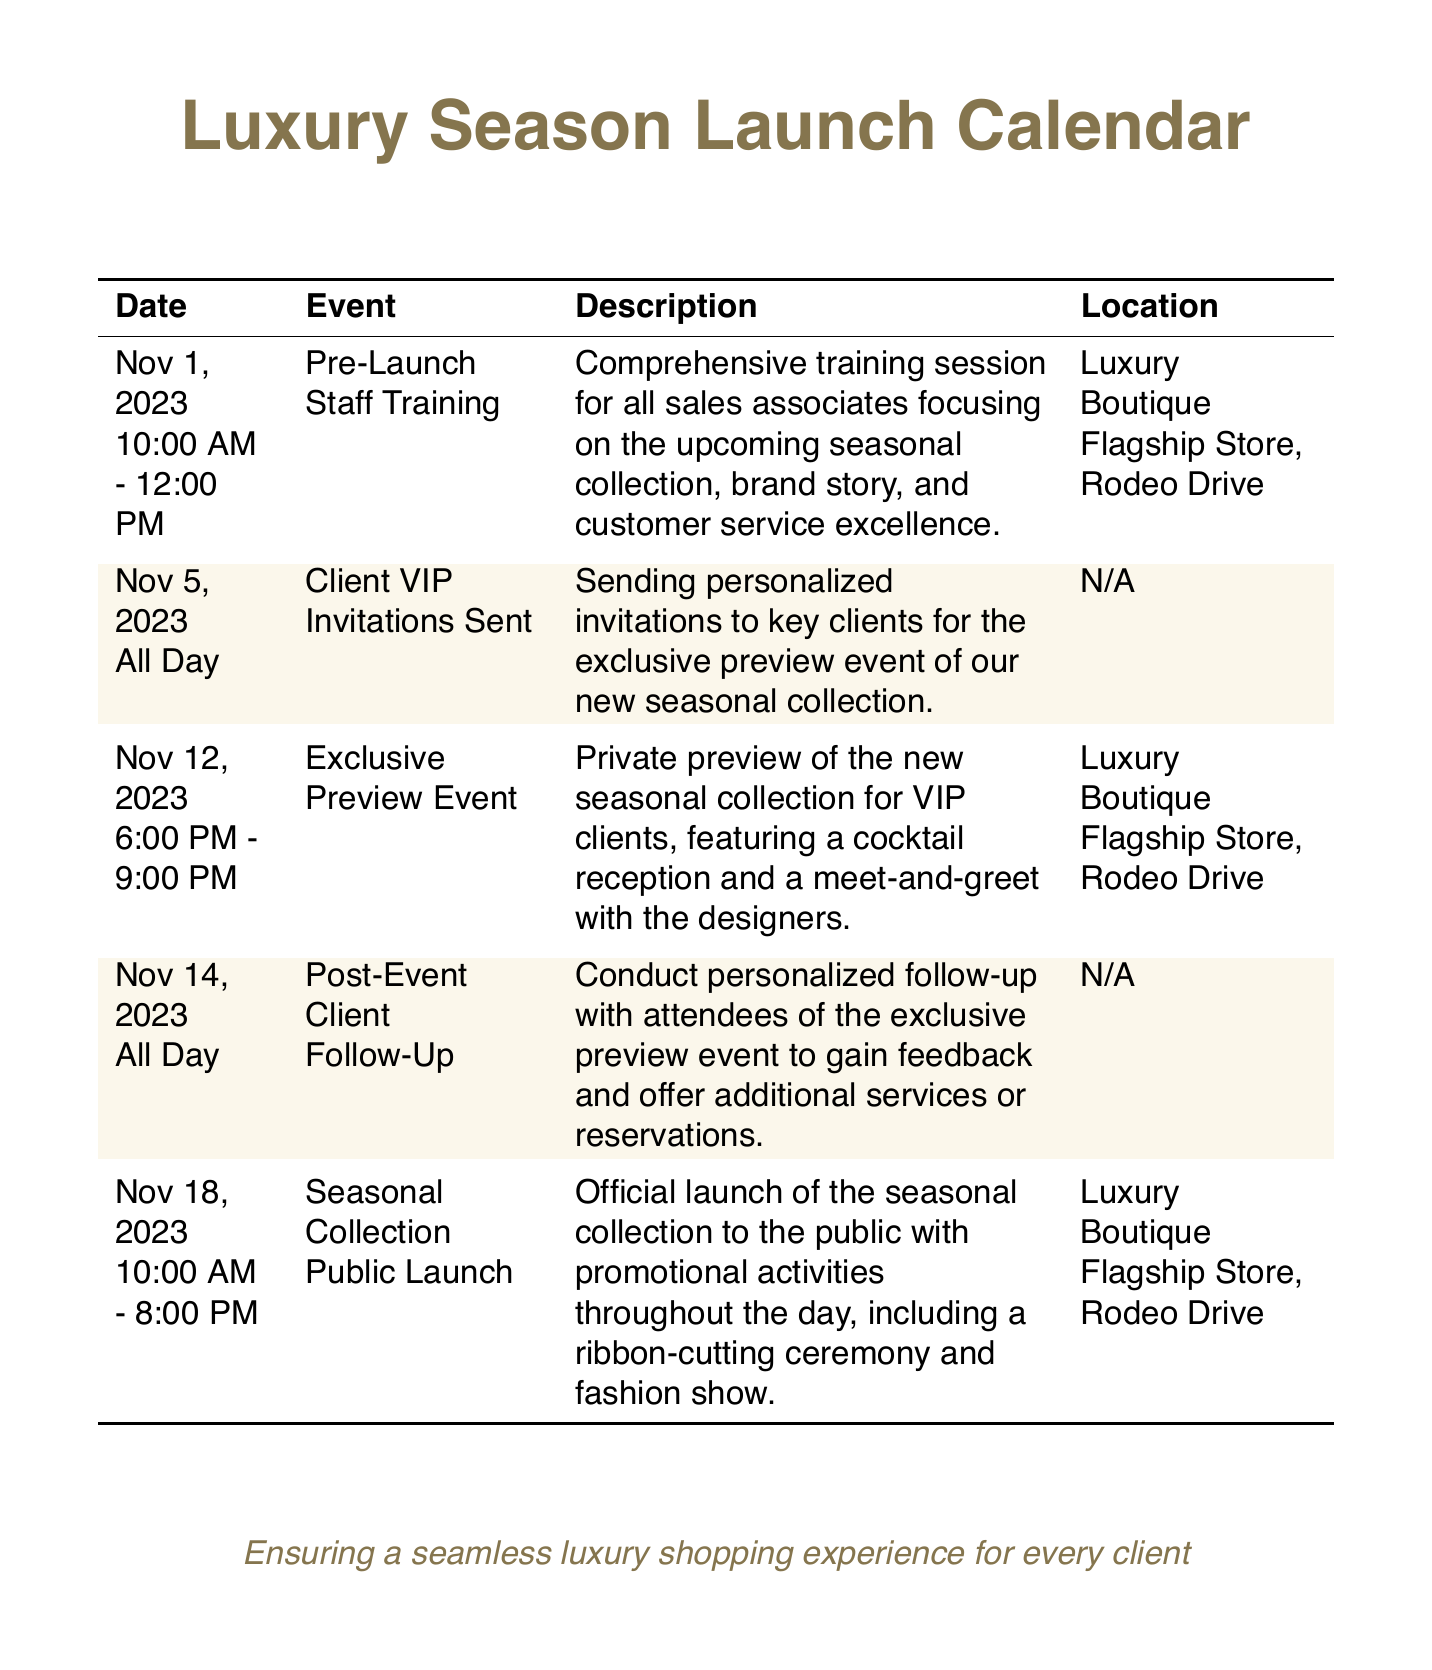what date is the pre-launch staff training scheduled for? The pre-launch staff training is scheduled for November 1, 2023, as mentioned in the document.
Answer: November 1, 2023 what time does the exclusive preview event start? The exclusive preview event starts at 6:00 PM, according to the event details provided.
Answer: 6:00 PM how long is the seasonal collection public launch event? The seasonal collection public launch event is scheduled for 10 hours, from 10:00 AM to 8:00 PM.
Answer: 10 hours where will the exclusive preview event take place? The exclusive preview event takes place at the Luxury Boutique Flagship Store, Rodeo Drive, as specified in the location details.
Answer: Luxury Boutique Flagship Store, Rodeo Drive what occurs on November 5, 2023? On November 5, 2023, personalized invitations are sent to key clients, indicating the event's preparations.
Answer: Client VIP Invitations Sent how many days are between the exclusive preview event and the public launch? The exclusive preview event occurs on November 12, 2023, and the public launch happens on November 18, 2023, resulting in a span of 6 days.
Answer: 6 days what event follows the exclusive preview event in the calendar? The event following the exclusive preview is the post-event client follow-up scheduled for November 14, 2023.
Answer: Post-Event Client Follow-Up what is the main focus of the pre-launch staff training? The pre-launch staff training focuses on customer service excellence, the upcoming seasonal collection, and the brand story as noted in the description.
Answer: Customer service excellence 